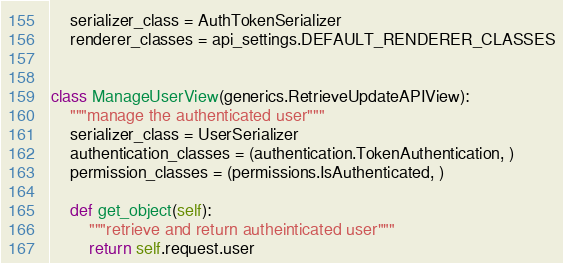<code> <loc_0><loc_0><loc_500><loc_500><_Python_>    serializer_class = AuthTokenSerializer
    renderer_classes = api_settings.DEFAULT_RENDERER_CLASSES


class ManageUserView(generics.RetrieveUpdateAPIView):
    """manage the authenticated user"""
    serializer_class = UserSerializer
    authentication_classes = (authentication.TokenAuthentication, )
    permission_classes = (permissions.IsAuthenticated, )

    def get_object(self):
        """retrieve and return autheinticated user"""
        return self.request.user
</code> 